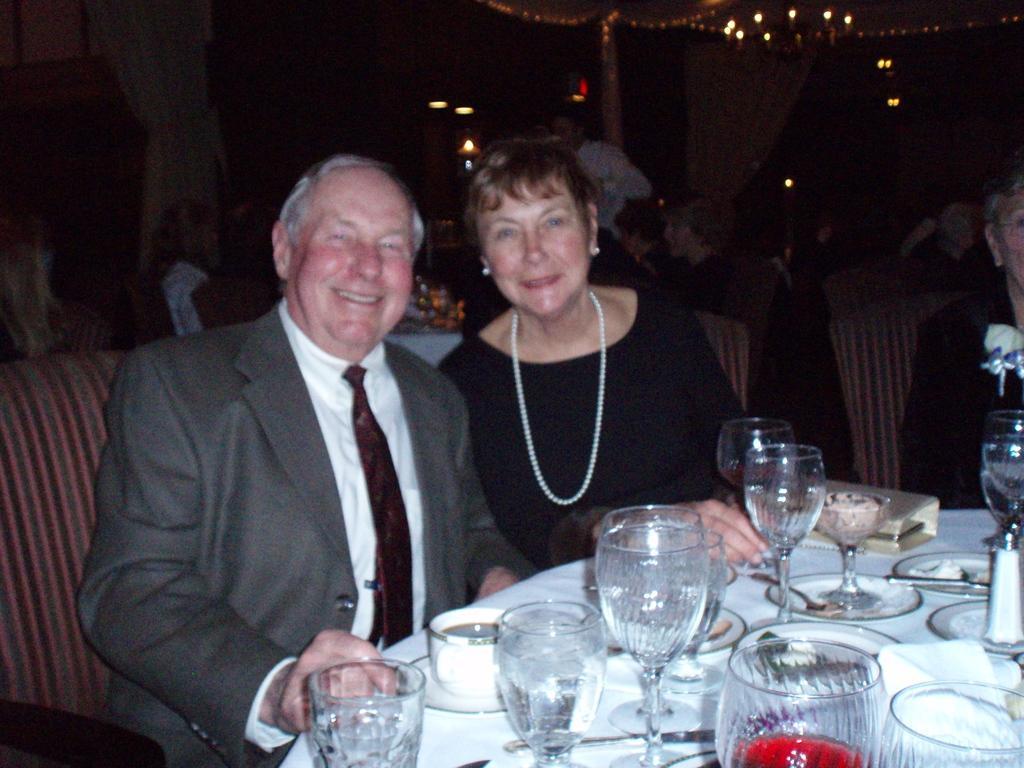Describe this image in one or two sentences. In this picture we can see a man and a woman sitting on a chair and smiling and in front of them on the table we can see glasses, plates, cup, saucer, purse and in the background we can see some people, lights, curtains. 